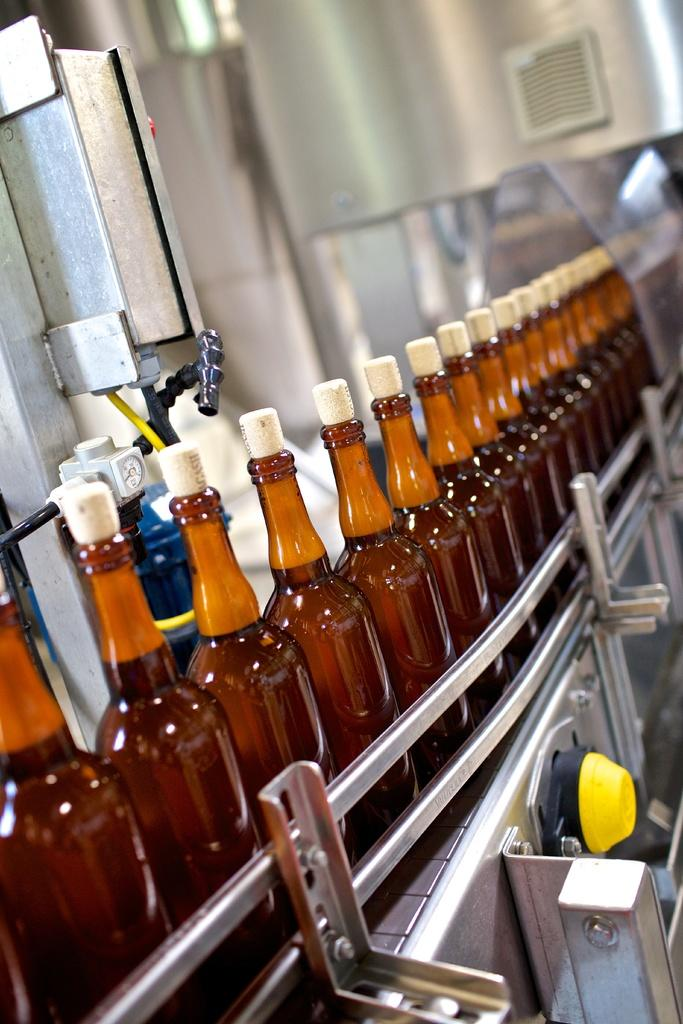What type of containers are present in the image? There are bottles with corks in the image. What can be seen on the left side of the image? There is a metal object on the left side of the image. Where are the bottles located in the image? The bottles are on a machine. What type of straw is growing on the coast in the image? There is no straw or coast present in the image; it features bottles with corks and a metal object. What type of pipe can be seen connecting the bottles in the image? There is no pipe connecting the bottles in the image; they are simply on a machine. 